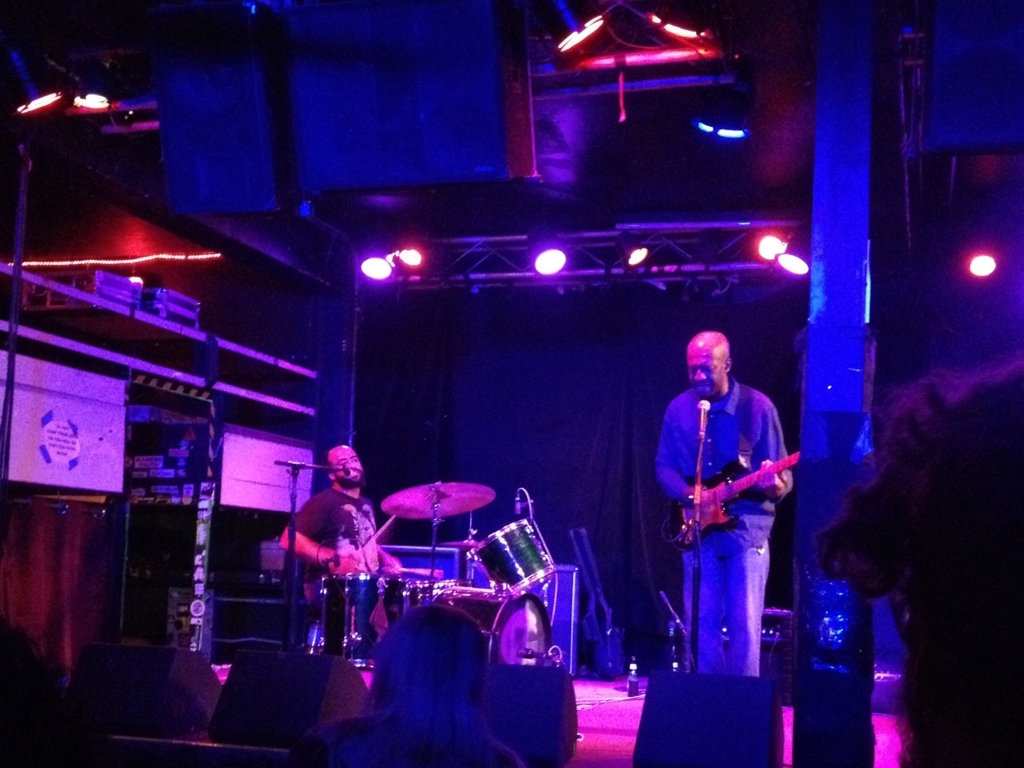How does the distance between the main subject and the shooting lens affect the image quality?
A. details are very clear
B. image quality is improved
C. sharpness is enhanced
D. details are not prominent enough The distance between the main subject and the camera lens can significantly alter the image's perception. A closer proximity tends to enhance details and sharpness, making A, B, and C correct to varying degrees, depending on other factors like lens quality and settings. However, answer D is only partially correct; if the subject is too far, details may indeed become less prominent, but this doesn't intrinsically signify poor image quality. The overall clarity also depends on the camera's focus abilities, depth of field, and the photographer's intent with the composition. 